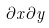Convert formula to latex. <formula><loc_0><loc_0><loc_500><loc_500>{ \partial x \partial y }</formula> 